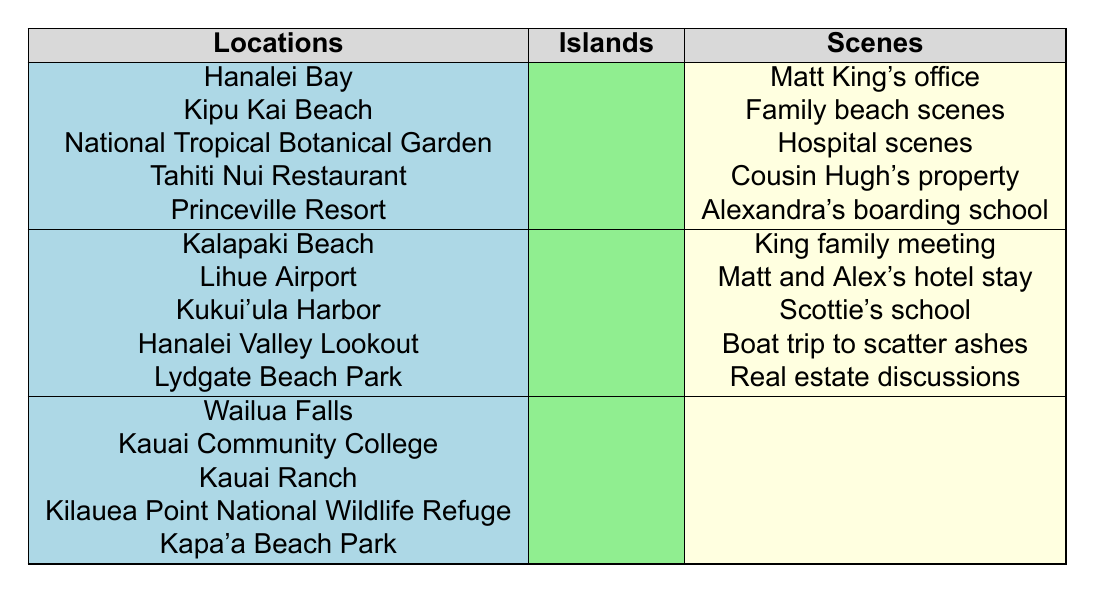What is the filming location for Matt King’s office? The table lists "Matt King's office" under the scenes column, which corresponds to "Hanalei Bay" in the locations column.
Answer: Hanalei Bay Which island has the most filming locations listed? The table shows five filming locations grouped under Kauai, three locations under Oahu, and five under Big Island, making it unclear if Kauai or Big Island has more. However, since each island has the same count under locations, the answer is that both Kauai and Big Island have the same number of locations listed, totaling to five each.
Answer: Kauai and Big Island Do any of the scenes involve Scottie King? The "Scottie's school" scene is listed in connection with one location under Oahu, indicating that Scottie King is included in this scene.
Answer: Yes Which character is present during the family beach scenes? By inspecting the scenes and character presence, we can determine which characters relate to "Family beach scenes." No specific character is listed directly in the table about this scene, therefore we cannot ascertain which character is directly involved.
Answer: Cannot determine How many days were required for filming at Lihue Airport and Kalapaki Beach combined? Each location is associated with one scene, but no specific days of shooting are provided in the table. Based on common knowledge, Lihue Airport and Kalapaki Beach would typically require multiple days due to logistical arrangements, but this specific detail is not shown in the data.
Answer: Cannot calculate Is there a scene corresponding with Kapa'a Beach Park? The table doesn’t provide any scenes under the "Kapa'a Beach Park" location, indicating that it was not used for filming in this regard.
Answer: No What is the total number of different scenes listed across all locations? By tallying up each unique scene, we can find that there are a total of 9 scenes listed: "Matt King's office," "Family beach scenes," "Hospital scenes," "Cousin Hugh's property," "Alexandra's boarding school," "King family meeting," "Matt and Alex's hotel stay," "Scottie's school," "Boat trip to scatter ashes," and "Real estate discussions." Therefore, the total is 9.
Answer: 9 Which location in Kauai is associated with the family meeting scene? The family meeting scene listed in the table corresponds to Kalapaki Beach, which is noted as an Oahu location. Kauai does not have a scene that directly matches the family meeting.
Answer: None in Kauai Does the film feature any scenes set on a specific island other than Kauai? The table contains locations mapped to both Oahu and Big Island, along with Kauai, suggesting that filming did indeed occur on islands besides Kauai.
Answer: Yes What is the total number of character appearances associated with the filming locations? The total number of unique characters listed is 10, indicating a range of appearances across different scenes and locations, suggesting strong character interconnection throughout the filming process.
Answer: 10 